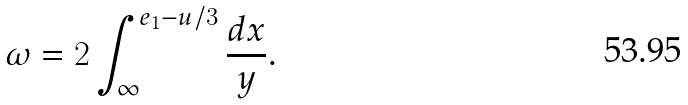Convert formula to latex. <formula><loc_0><loc_0><loc_500><loc_500>\omega = 2 \int _ { \infty } ^ { e _ { 1 } - u / 3 } \frac { d x } y .</formula> 